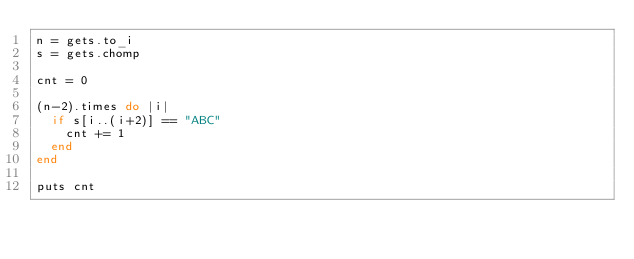Convert code to text. <code><loc_0><loc_0><loc_500><loc_500><_Ruby_>n = gets.to_i
s = gets.chomp

cnt = 0

(n-2).times do |i|
  if s[i..(i+2)] == "ABC"
    cnt += 1
  end
end

puts cnt</code> 